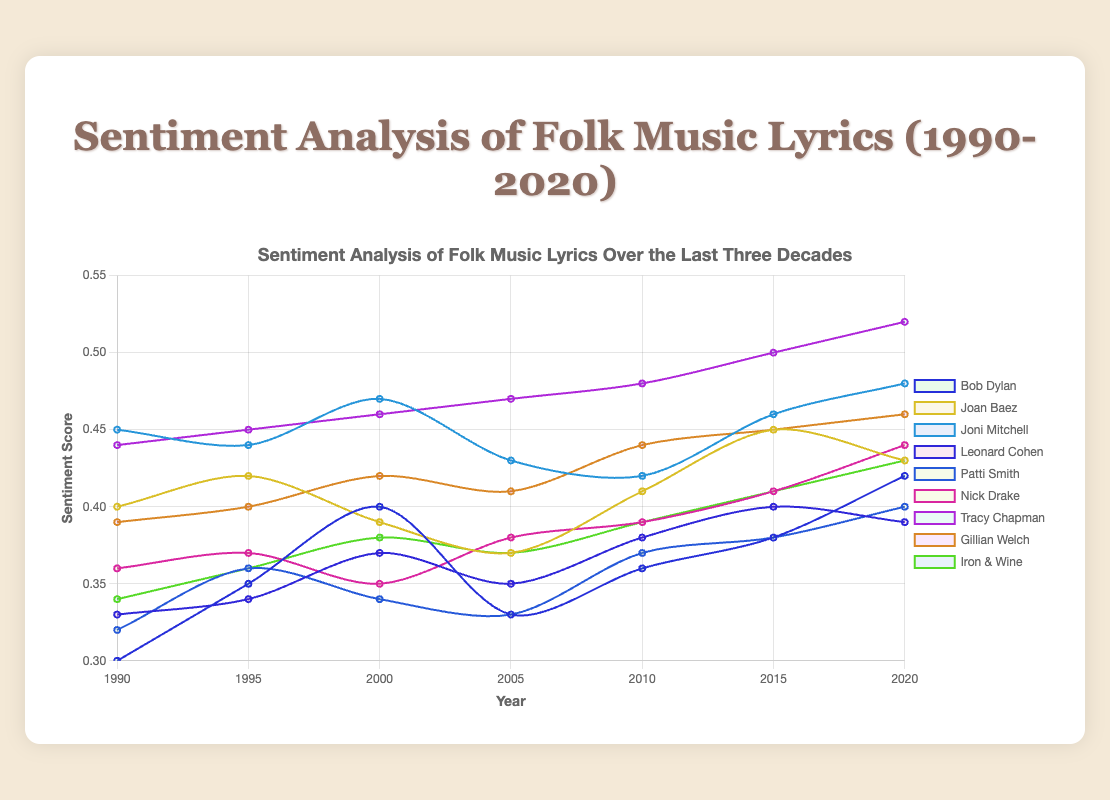What is the trend in Bob Dylan's sentiment scores from 1990 to 2020? The visual shows an increase in sentiment scores over the years for Bob Dylan, starting from 0.3 in 1990 and rising to 0.42 in 2020.
Answer: Increasing Which artist has the highest sentiment score in 2020? Tracy Chapman has the highest sentiment score in 2020, with a score of 0.52, higher than any other artist on the chart.
Answer: Tracy Chapman Comparing Joan Baez and Leonard Cohen, who had a higher average sentiment score over the entire period? Joan Baez's sentiment scores are [0.4, 0.42, 0.39, 0.37, 0.41, 0.45, 0.43]. Adding them: 0.4 + 0.42 + 0.39 + 0.37 + 0.41 + 0.45 + 0.43 = 2.87. Average is 2.87 / 7 ≈ 0.41. Leonard Cohen's scores are [0.33, 0.34, 0.37, 0.35, 0.38, 0.40, 0.39]. Adding them: 0.33 + 0.34 + 0.37 + 0.35 + 0.38 + 0.40 + 0.39 = 2.56. Average is 2.56 / 7 ≈ 0.37.
Answer: Joan Baez Whose sentiment score saw the largest drop between any two consecutive years? Bob Dylan's sentiment score fell from 0.4 in 2000 to 0.33 in 2005, a drop of 0.07, which is the largest drop between any two consecutive years for any artists in the dataset.
Answer: Bob Dylan What is the average sentiment score for Joni Mitchell in the decade from 2000 to 2010? Joni Mitchell's sentiment scores in the decade from 2000 to 2010 are 0.47 (2000), 0.43 (2005), and 0.42 (2010). The sum is 0.47 + 0.43 + 0.42 = 1.32. The average is 1.32 / 3 ≈ 0.44.
Answer: 0.44 How do sentiment scores of Iron & Wine in 2020 compare to that of Tracy Chapman in 2015? Iron & Wine's sentiment score in 2020 is 0.43, while Tracy Chapman's score in 2015 is 0.50. Tracy Chapman's score in 2015 is higher than Iron & Wine's score in 2020.
Answer: Tracy Chapman's score in 2015 is higher Which artist shows the most consistent sentiment score trend from 1990 to 2020? Joni Mitchell's sentiment scores are [0.45, 0.44, 0.47, 0.43, 0.42, 0.46, 0.48], which consistently stay within a narrow range and show small fluctuations.
Answer: Joni Mitchell 